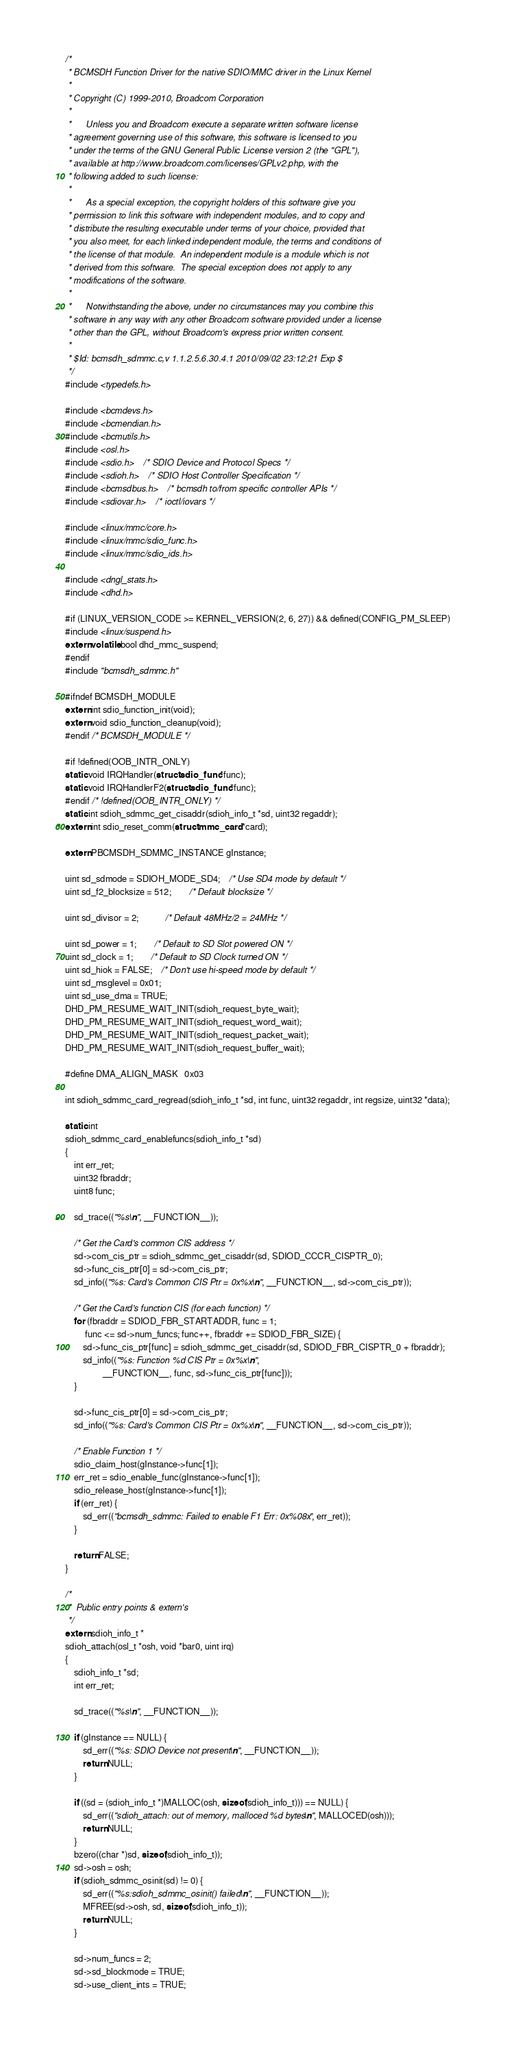Convert code to text. <code><loc_0><loc_0><loc_500><loc_500><_C_>/*
 * BCMSDH Function Driver for the native SDIO/MMC driver in the Linux Kernel
 *
 * Copyright (C) 1999-2010, Broadcom Corporation
 * 
 *      Unless you and Broadcom execute a separate written software license
 * agreement governing use of this software, this software is licensed to you
 * under the terms of the GNU General Public License version 2 (the "GPL"),
 * available at http://www.broadcom.com/licenses/GPLv2.php, with the
 * following added to such license:
 * 
 *      As a special exception, the copyright holders of this software give you
 * permission to link this software with independent modules, and to copy and
 * distribute the resulting executable under terms of your choice, provided that
 * you also meet, for each linked independent module, the terms and conditions of
 * the license of that module.  An independent module is a module which is not
 * derived from this software.  The special exception does not apply to any
 * modifications of the software.
 * 
 *      Notwithstanding the above, under no circumstances may you combine this
 * software in any way with any other Broadcom software provided under a license
 * other than the GPL, without Broadcom's express prior written consent.
 *
 * $Id: bcmsdh_sdmmc.c,v 1.1.2.5.6.30.4.1 2010/09/02 23:12:21 Exp $
 */
#include <typedefs.h>

#include <bcmdevs.h>
#include <bcmendian.h>
#include <bcmutils.h>
#include <osl.h>
#include <sdio.h>	/* SDIO Device and Protocol Specs */
#include <sdioh.h>	/* SDIO Host Controller Specification */
#include <bcmsdbus.h>	/* bcmsdh to/from specific controller APIs */
#include <sdiovar.h>	/* ioctl/iovars */

#include <linux/mmc/core.h>
#include <linux/mmc/sdio_func.h>
#include <linux/mmc/sdio_ids.h>

#include <dngl_stats.h>
#include <dhd.h>

#if (LINUX_VERSION_CODE >= KERNEL_VERSION(2, 6, 27)) && defined(CONFIG_PM_SLEEP)
#include <linux/suspend.h>
extern volatile bool dhd_mmc_suspend;
#endif
#include "bcmsdh_sdmmc.h"

#ifndef BCMSDH_MODULE
extern int sdio_function_init(void);
extern void sdio_function_cleanup(void);
#endif /* BCMSDH_MODULE */

#if !defined(OOB_INTR_ONLY)
static void IRQHandler(struct sdio_func *func);
static void IRQHandlerF2(struct sdio_func *func);
#endif /* !defined(OOB_INTR_ONLY) */
static int sdioh_sdmmc_get_cisaddr(sdioh_info_t *sd, uint32 regaddr);
extern int sdio_reset_comm(struct mmc_card *card);

extern PBCMSDH_SDMMC_INSTANCE gInstance;

uint sd_sdmode = SDIOH_MODE_SD4;	/* Use SD4 mode by default */
uint sd_f2_blocksize = 512;		/* Default blocksize */

uint sd_divisor = 2;			/* Default 48MHz/2 = 24MHz */

uint sd_power = 1;		/* Default to SD Slot powered ON */
uint sd_clock = 1;		/* Default to SD Clock turned ON */
uint sd_hiok = FALSE;	/* Don't use hi-speed mode by default */
uint sd_msglevel = 0x01;
uint sd_use_dma = TRUE;
DHD_PM_RESUME_WAIT_INIT(sdioh_request_byte_wait);
DHD_PM_RESUME_WAIT_INIT(sdioh_request_word_wait);
DHD_PM_RESUME_WAIT_INIT(sdioh_request_packet_wait);
DHD_PM_RESUME_WAIT_INIT(sdioh_request_buffer_wait);

#define DMA_ALIGN_MASK	0x03

int sdioh_sdmmc_card_regread(sdioh_info_t *sd, int func, uint32 regaddr, int regsize, uint32 *data);

static int
sdioh_sdmmc_card_enablefuncs(sdioh_info_t *sd)
{
	int err_ret;
	uint32 fbraddr;
	uint8 func;

	sd_trace(("%s\n", __FUNCTION__));

	/* Get the Card's common CIS address */
	sd->com_cis_ptr = sdioh_sdmmc_get_cisaddr(sd, SDIOD_CCCR_CISPTR_0);
	sd->func_cis_ptr[0] = sd->com_cis_ptr;
	sd_info(("%s: Card's Common CIS Ptr = 0x%x\n", __FUNCTION__, sd->com_cis_ptr));

	/* Get the Card's function CIS (for each function) */
	for (fbraddr = SDIOD_FBR_STARTADDR, func = 1;
	     func <= sd->num_funcs; func++, fbraddr += SDIOD_FBR_SIZE) {
		sd->func_cis_ptr[func] = sdioh_sdmmc_get_cisaddr(sd, SDIOD_FBR_CISPTR_0 + fbraddr);
		sd_info(("%s: Function %d CIS Ptr = 0x%x\n",
		         __FUNCTION__, func, sd->func_cis_ptr[func]));
	}

	sd->func_cis_ptr[0] = sd->com_cis_ptr;
	sd_info(("%s: Card's Common CIS Ptr = 0x%x\n", __FUNCTION__, sd->com_cis_ptr));

	/* Enable Function 1 */
	sdio_claim_host(gInstance->func[1]);
	err_ret = sdio_enable_func(gInstance->func[1]);
	sdio_release_host(gInstance->func[1]);
	if (err_ret) {
		sd_err(("bcmsdh_sdmmc: Failed to enable F1 Err: 0x%08x", err_ret));
	}

	return FALSE;
}

/*
 *	Public entry points & extern's
 */
extern sdioh_info_t *
sdioh_attach(osl_t *osh, void *bar0, uint irq)
{
	sdioh_info_t *sd;
	int err_ret;

	sd_trace(("%s\n", __FUNCTION__));

	if (gInstance == NULL) {
		sd_err(("%s: SDIO Device not present\n", __FUNCTION__));
		return NULL;
	}

	if ((sd = (sdioh_info_t *)MALLOC(osh, sizeof(sdioh_info_t))) == NULL) {
		sd_err(("sdioh_attach: out of memory, malloced %d bytes\n", MALLOCED(osh)));
		return NULL;
	}
	bzero((char *)sd, sizeof(sdioh_info_t));
	sd->osh = osh;
	if (sdioh_sdmmc_osinit(sd) != 0) {
		sd_err(("%s:sdioh_sdmmc_osinit() failed\n", __FUNCTION__));
		MFREE(sd->osh, sd, sizeof(sdioh_info_t));
		return NULL;
	}

	sd->num_funcs = 2;
	sd->sd_blockmode = TRUE;
	sd->use_client_ints = TRUE;</code> 